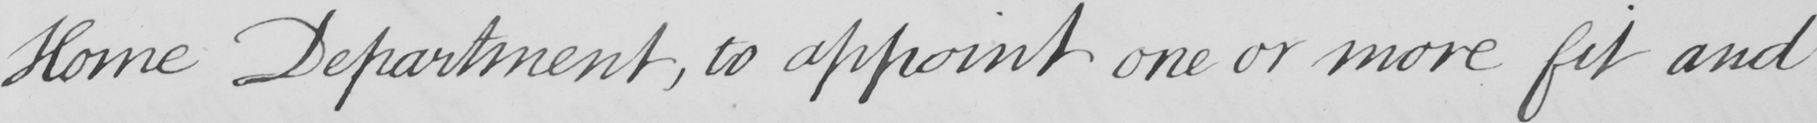Please provide the text content of this handwritten line. Home Department , to appoint one or more fit and 